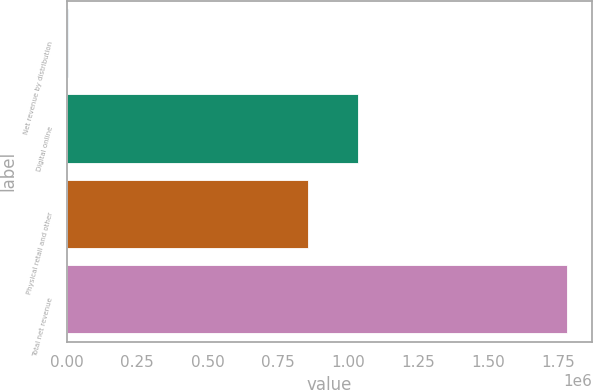Convert chart to OTSL. <chart><loc_0><loc_0><loc_500><loc_500><bar_chart><fcel>Net revenue by distribution<fcel>Digital online<fcel>Physical retail and other<fcel>Total net revenue<nl><fcel>2017<fcel>1.03579e+06<fcel>858014<fcel>1.77975e+06<nl></chart> 